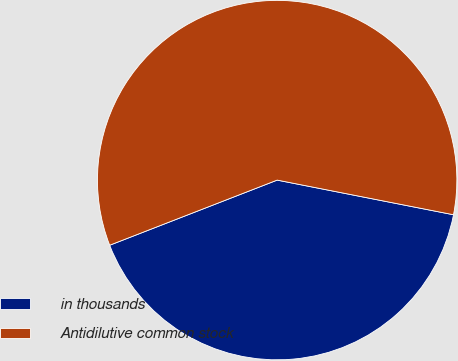<chart> <loc_0><loc_0><loc_500><loc_500><pie_chart><fcel>in thousands<fcel>Antidilutive common stock<nl><fcel>41.01%<fcel>58.99%<nl></chart> 